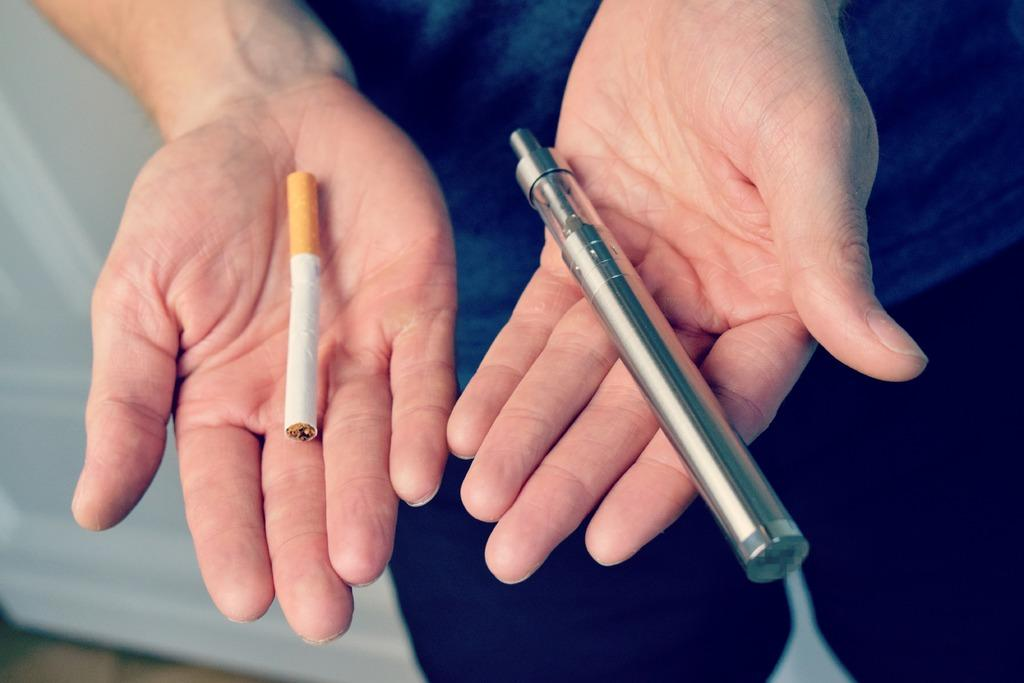What is the main subject of the image? There is a person in the image. What is the person holding in the image? The person is holding a cigarette and another object. What can be observed about the background of the image? The background of the image is white. How many tigers can be seen in the image? There are no tigers present in the image. What is the price of the object the person is holding in the image? The price of the object cannot be determined from the image. 